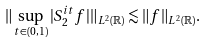Convert formula to latex. <formula><loc_0><loc_0><loc_500><loc_500>\| \sup _ { t \in ( 0 , 1 ) } | S ^ { i t } _ { 2 } f | \| _ { L ^ { 2 } ( \mathbb { R } ) } \lesssim \| f \| _ { L ^ { 2 } ( \mathbb { R } ) } .</formula> 